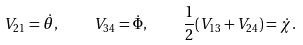<formula> <loc_0><loc_0><loc_500><loc_500>V _ { 2 1 } = \dot { \theta } , \quad V _ { 3 4 } = \dot { \Phi } , \quad \frac { 1 } { 2 } ( V _ { 1 3 } + V _ { 2 4 } ) = \dot { \chi } .</formula> 